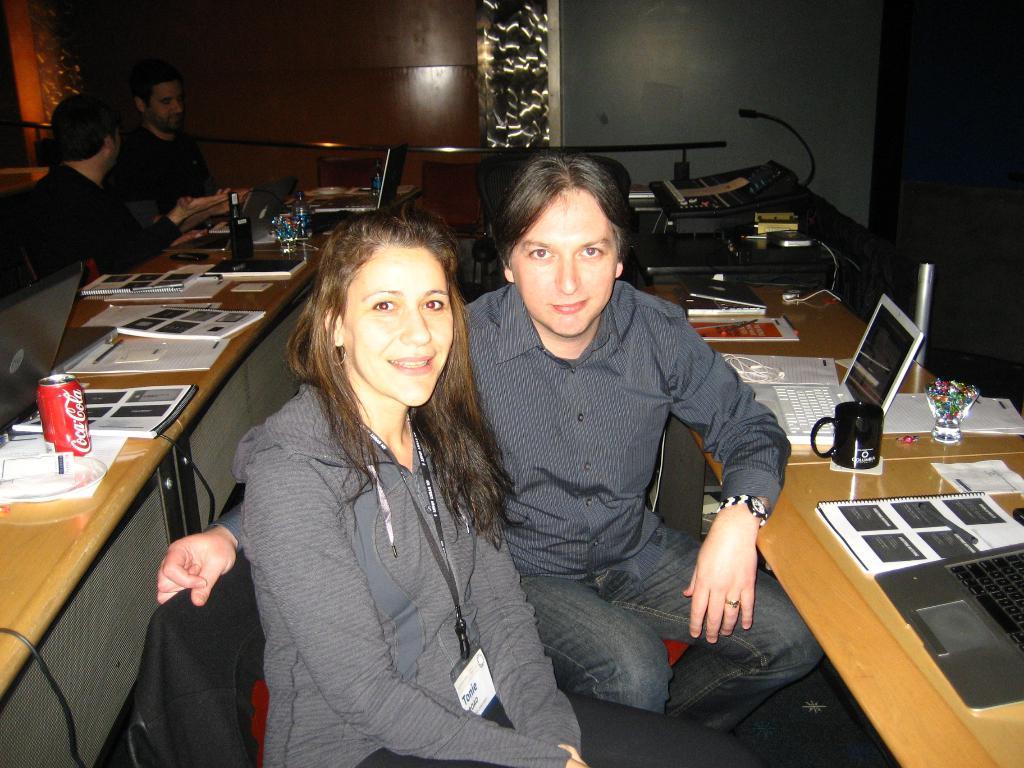How would you summarize this image in a sentence or two? In this image I can see few people sitting and wearing the black and grey color dresses. These people are siting in-front of tables. On the tables I can see the laptop, books, tin, decorative objects, bottles and many objects. In the background I can see the wall. 